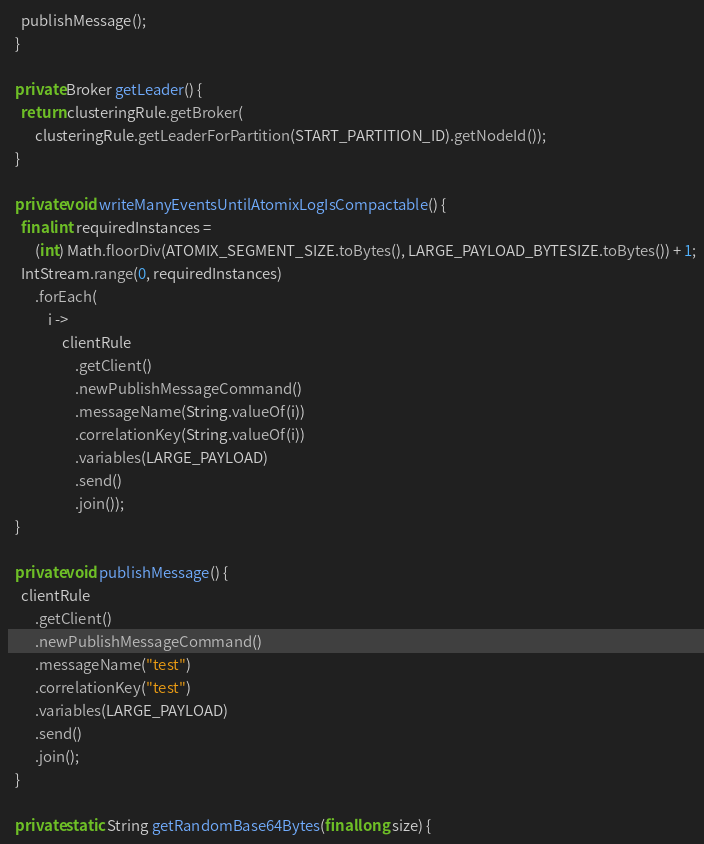Convert code to text. <code><loc_0><loc_0><loc_500><loc_500><_Java_>
    publishMessage();
  }

  private Broker getLeader() {
    return clusteringRule.getBroker(
        clusteringRule.getLeaderForPartition(START_PARTITION_ID).getNodeId());
  }

  private void writeManyEventsUntilAtomixLogIsCompactable() {
    final int requiredInstances =
        (int) Math.floorDiv(ATOMIX_SEGMENT_SIZE.toBytes(), LARGE_PAYLOAD_BYTESIZE.toBytes()) + 1;
    IntStream.range(0, requiredInstances)
        .forEach(
            i ->
                clientRule
                    .getClient()
                    .newPublishMessageCommand()
                    .messageName(String.valueOf(i))
                    .correlationKey(String.valueOf(i))
                    .variables(LARGE_PAYLOAD)
                    .send()
                    .join());
  }

  private void publishMessage() {
    clientRule
        .getClient()
        .newPublishMessageCommand()
        .messageName("test")
        .correlationKey("test")
        .variables(LARGE_PAYLOAD)
        .send()
        .join();
  }

  private static String getRandomBase64Bytes(final long size) {</code> 